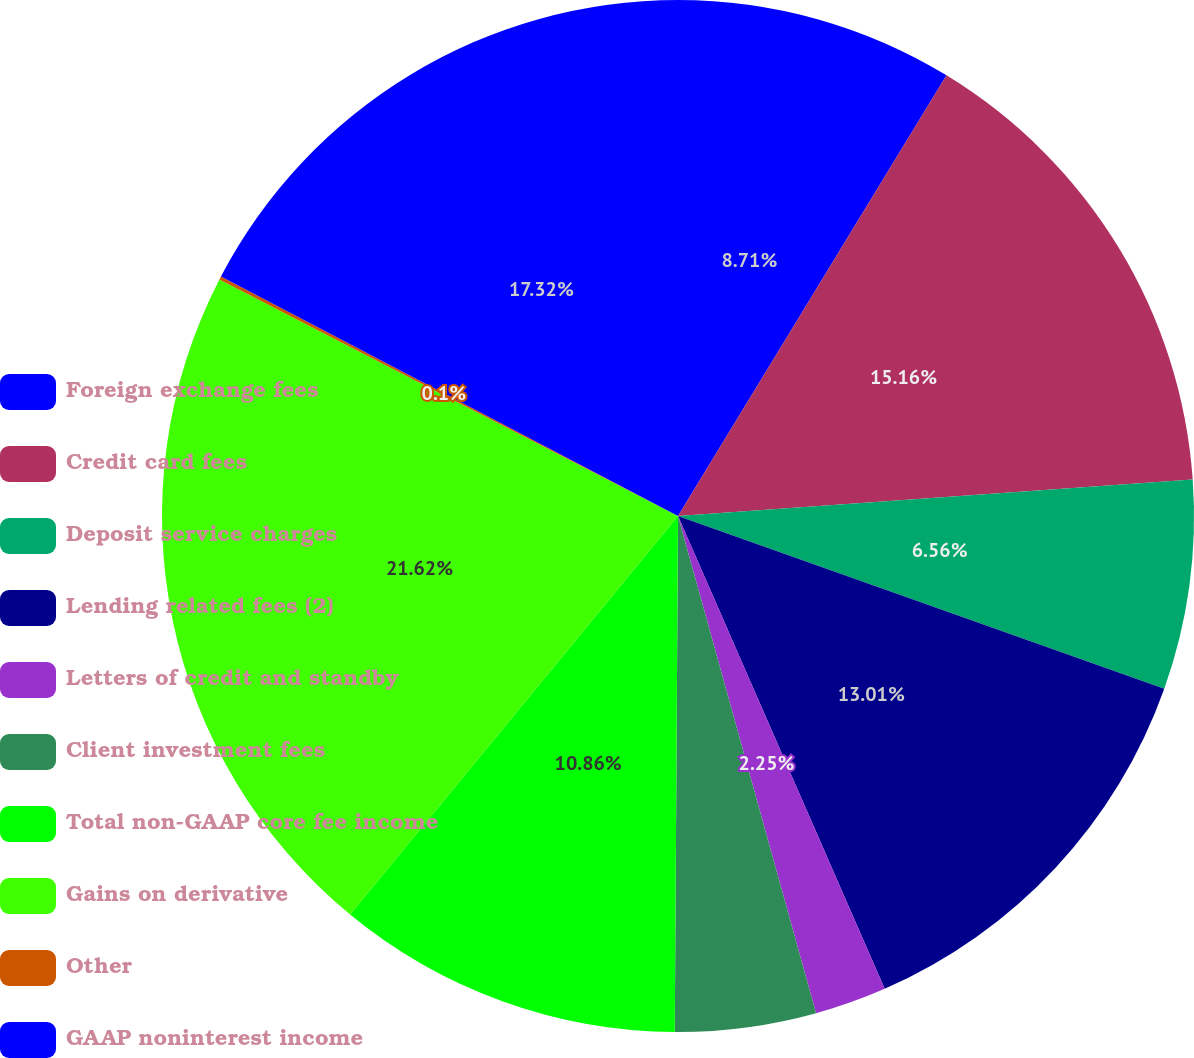<chart> <loc_0><loc_0><loc_500><loc_500><pie_chart><fcel>Foreign exchange fees<fcel>Credit card fees<fcel>Deposit service charges<fcel>Lending related fees (2)<fcel>Letters of credit and standby<fcel>Client investment fees<fcel>Total non-GAAP core fee income<fcel>Gains on derivative<fcel>Other<fcel>GAAP noninterest income<nl><fcel>8.71%<fcel>15.16%<fcel>6.56%<fcel>13.01%<fcel>2.25%<fcel>4.41%<fcel>10.86%<fcel>21.62%<fcel>0.1%<fcel>17.32%<nl></chart> 